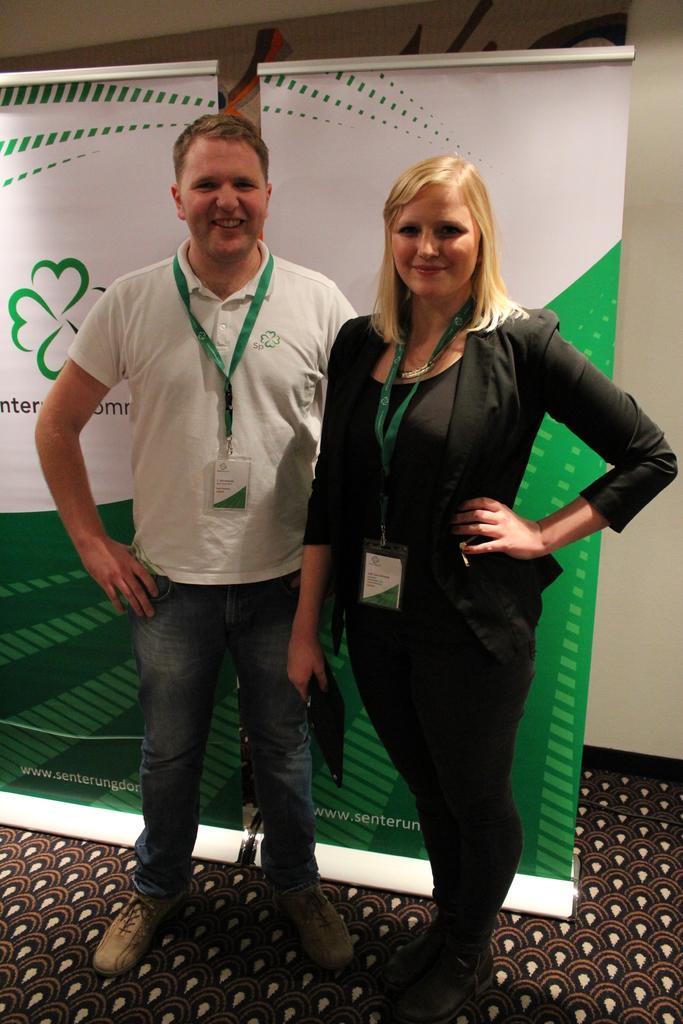How would you summarize this image in a sentence or two? In the front of the image a woman and a man are standing and wore ID cards. In the background we can see banners and wall. Floor with carpet. 